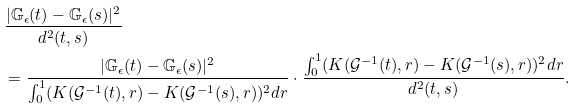<formula> <loc_0><loc_0><loc_500><loc_500>& \frac { | \mathbb { G } _ { \epsilon } ( t ) - \mathbb { G } _ { \epsilon } ( s ) | ^ { 2 } } { d ^ { 2 } ( t , s ) } \\ & = \frac { | \mathbb { G } _ { \epsilon } ( t ) - \mathbb { G } _ { \epsilon } ( s ) | ^ { 2 } } { \int ^ { 1 } _ { 0 } ( K ( \mathcal { G } ^ { - 1 } ( t ) , r ) - K ( \mathcal { G } ^ { - 1 } ( s ) , r ) ) ^ { 2 } d r } \cdot \frac { \int ^ { 1 } _ { 0 } ( K ( \mathcal { G } ^ { - 1 } ( t ) , r ) - K ( \mathcal { G } ^ { - 1 } ( s ) , r ) ) ^ { 2 } d r } { d ^ { 2 } ( t , s ) } .</formula> 